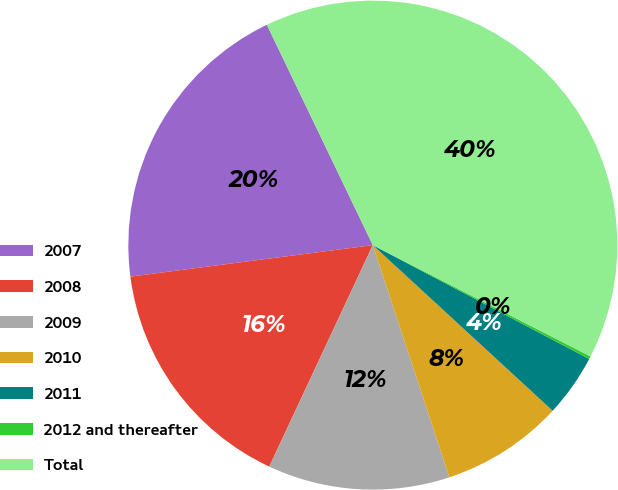Convert chart to OTSL. <chart><loc_0><loc_0><loc_500><loc_500><pie_chart><fcel>2007<fcel>2008<fcel>2009<fcel>2010<fcel>2011<fcel>2012 and thereafter<fcel>Total<nl><fcel>19.92%<fcel>15.98%<fcel>12.03%<fcel>8.08%<fcel>4.14%<fcel>0.19%<fcel>39.65%<nl></chart> 